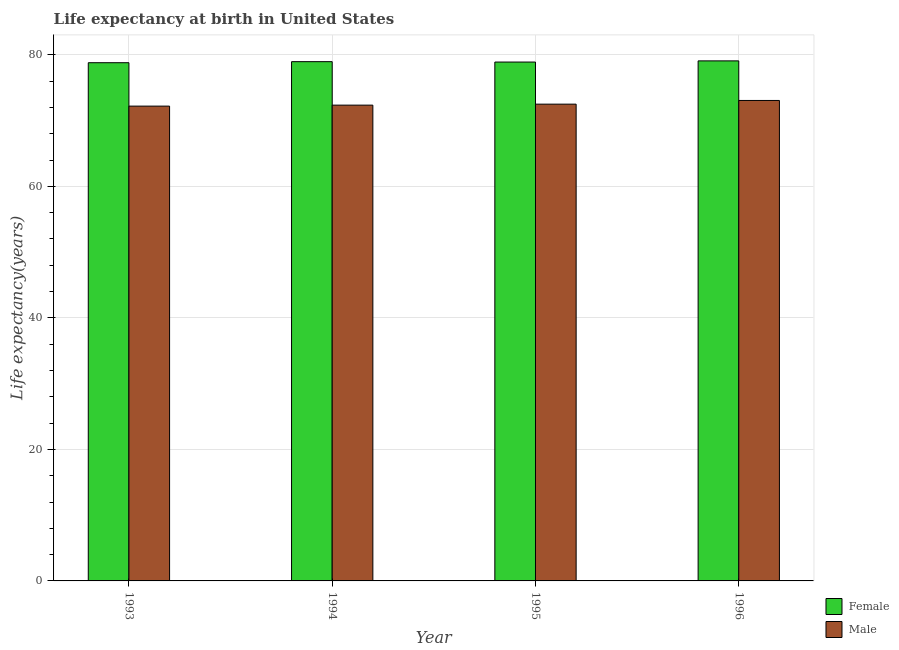How many groups of bars are there?
Your answer should be very brief. 4. Are the number of bars per tick equal to the number of legend labels?
Your answer should be very brief. Yes. Are the number of bars on each tick of the X-axis equal?
Make the answer very short. Yes. How many bars are there on the 1st tick from the left?
Offer a terse response. 2. What is the life expectancy(male) in 1995?
Your response must be concise. 72.5. Across all years, what is the maximum life expectancy(male)?
Your answer should be very brief. 73.06. Across all years, what is the minimum life expectancy(female)?
Offer a terse response. 78.8. In which year was the life expectancy(female) minimum?
Your answer should be very brief. 1993. What is the total life expectancy(female) in the graph?
Offer a very short reply. 315.74. What is the difference between the life expectancy(male) in 1993 and that in 1995?
Your answer should be very brief. -0.3. What is the difference between the life expectancy(male) in 1994 and the life expectancy(female) in 1993?
Provide a short and direct response. 0.15. What is the average life expectancy(male) per year?
Provide a succinct answer. 72.53. In the year 1994, what is the difference between the life expectancy(female) and life expectancy(male)?
Provide a short and direct response. 0. What is the ratio of the life expectancy(female) in 1993 to that in 1995?
Provide a succinct answer. 1. Is the life expectancy(female) in 1993 less than that in 1996?
Your response must be concise. Yes. What is the difference between the highest and the second highest life expectancy(male)?
Provide a short and direct response. 0.56. What is the difference between the highest and the lowest life expectancy(male)?
Provide a short and direct response. 0.86. In how many years, is the life expectancy(male) greater than the average life expectancy(male) taken over all years?
Make the answer very short. 1. Is the sum of the life expectancy(female) in 1993 and 1996 greater than the maximum life expectancy(male) across all years?
Provide a succinct answer. Yes. What does the 1st bar from the left in 1993 represents?
Provide a succinct answer. Female. What does the 1st bar from the right in 1993 represents?
Give a very brief answer. Male. How many bars are there?
Your response must be concise. 8. What is the difference between two consecutive major ticks on the Y-axis?
Provide a short and direct response. 20. Are the values on the major ticks of Y-axis written in scientific E-notation?
Offer a very short reply. No. Does the graph contain any zero values?
Give a very brief answer. No. Does the graph contain grids?
Your answer should be compact. Yes. How many legend labels are there?
Keep it short and to the point. 2. What is the title of the graph?
Offer a terse response. Life expectancy at birth in United States. Does "Pregnant women" appear as one of the legend labels in the graph?
Your answer should be compact. No. What is the label or title of the Y-axis?
Your response must be concise. Life expectancy(years). What is the Life expectancy(years) in Female in 1993?
Provide a short and direct response. 78.8. What is the Life expectancy(years) in Male in 1993?
Make the answer very short. 72.2. What is the Life expectancy(years) in Female in 1994?
Offer a terse response. 78.96. What is the Life expectancy(years) of Male in 1994?
Provide a succinct answer. 72.35. What is the Life expectancy(years) of Female in 1995?
Provide a short and direct response. 78.9. What is the Life expectancy(years) in Male in 1995?
Keep it short and to the point. 72.5. What is the Life expectancy(years) of Female in 1996?
Offer a terse response. 79.08. What is the Life expectancy(years) of Male in 1996?
Provide a succinct answer. 73.06. Across all years, what is the maximum Life expectancy(years) of Female?
Keep it short and to the point. 79.08. Across all years, what is the maximum Life expectancy(years) in Male?
Give a very brief answer. 73.06. Across all years, what is the minimum Life expectancy(years) in Female?
Make the answer very short. 78.8. Across all years, what is the minimum Life expectancy(years) in Male?
Give a very brief answer. 72.2. What is the total Life expectancy(years) in Female in the graph?
Offer a terse response. 315.74. What is the total Life expectancy(years) in Male in the graph?
Offer a very short reply. 290.11. What is the difference between the Life expectancy(years) in Female in 1993 and that in 1994?
Keep it short and to the point. -0.16. What is the difference between the Life expectancy(years) in Male in 1993 and that in 1995?
Your response must be concise. -0.3. What is the difference between the Life expectancy(years) of Female in 1993 and that in 1996?
Provide a short and direct response. -0.28. What is the difference between the Life expectancy(years) of Male in 1993 and that in 1996?
Offer a very short reply. -0.86. What is the difference between the Life expectancy(years) in Female in 1994 and that in 1995?
Keep it short and to the point. 0.06. What is the difference between the Life expectancy(years) of Male in 1994 and that in 1995?
Your response must be concise. -0.15. What is the difference between the Life expectancy(years) in Female in 1994 and that in 1996?
Your answer should be very brief. -0.12. What is the difference between the Life expectancy(years) of Male in 1994 and that in 1996?
Ensure brevity in your answer.  -0.71. What is the difference between the Life expectancy(years) of Female in 1995 and that in 1996?
Your response must be concise. -0.18. What is the difference between the Life expectancy(years) of Male in 1995 and that in 1996?
Your response must be concise. -0.56. What is the difference between the Life expectancy(years) in Female in 1993 and the Life expectancy(years) in Male in 1994?
Provide a short and direct response. 6.45. What is the difference between the Life expectancy(years) of Female in 1993 and the Life expectancy(years) of Male in 1995?
Offer a terse response. 6.3. What is the difference between the Life expectancy(years) of Female in 1993 and the Life expectancy(years) of Male in 1996?
Your answer should be very brief. 5.74. What is the difference between the Life expectancy(years) of Female in 1994 and the Life expectancy(years) of Male in 1995?
Offer a very short reply. 6.46. What is the difference between the Life expectancy(years) in Female in 1994 and the Life expectancy(years) in Male in 1996?
Keep it short and to the point. 5.9. What is the difference between the Life expectancy(years) of Female in 1995 and the Life expectancy(years) of Male in 1996?
Give a very brief answer. 5.84. What is the average Life expectancy(years) of Female per year?
Offer a terse response. 78.94. What is the average Life expectancy(years) in Male per year?
Provide a short and direct response. 72.53. In the year 1994, what is the difference between the Life expectancy(years) in Female and Life expectancy(years) in Male?
Give a very brief answer. 6.61. In the year 1995, what is the difference between the Life expectancy(years) of Female and Life expectancy(years) of Male?
Your response must be concise. 6.4. In the year 1996, what is the difference between the Life expectancy(years) of Female and Life expectancy(years) of Male?
Ensure brevity in your answer.  6.02. What is the ratio of the Life expectancy(years) of Female in 1993 to that in 1994?
Ensure brevity in your answer.  1. What is the ratio of the Life expectancy(years) in Male in 1993 to that in 1996?
Your answer should be very brief. 0.99. What is the ratio of the Life expectancy(years) in Female in 1994 to that in 1996?
Offer a terse response. 1. What is the ratio of the Life expectancy(years) of Male in 1994 to that in 1996?
Your answer should be very brief. 0.99. What is the ratio of the Life expectancy(years) in Female in 1995 to that in 1996?
Your response must be concise. 1. What is the difference between the highest and the second highest Life expectancy(years) of Female?
Keep it short and to the point. 0.12. What is the difference between the highest and the second highest Life expectancy(years) of Male?
Provide a short and direct response. 0.56. What is the difference between the highest and the lowest Life expectancy(years) in Female?
Ensure brevity in your answer.  0.28. What is the difference between the highest and the lowest Life expectancy(years) of Male?
Make the answer very short. 0.86. 